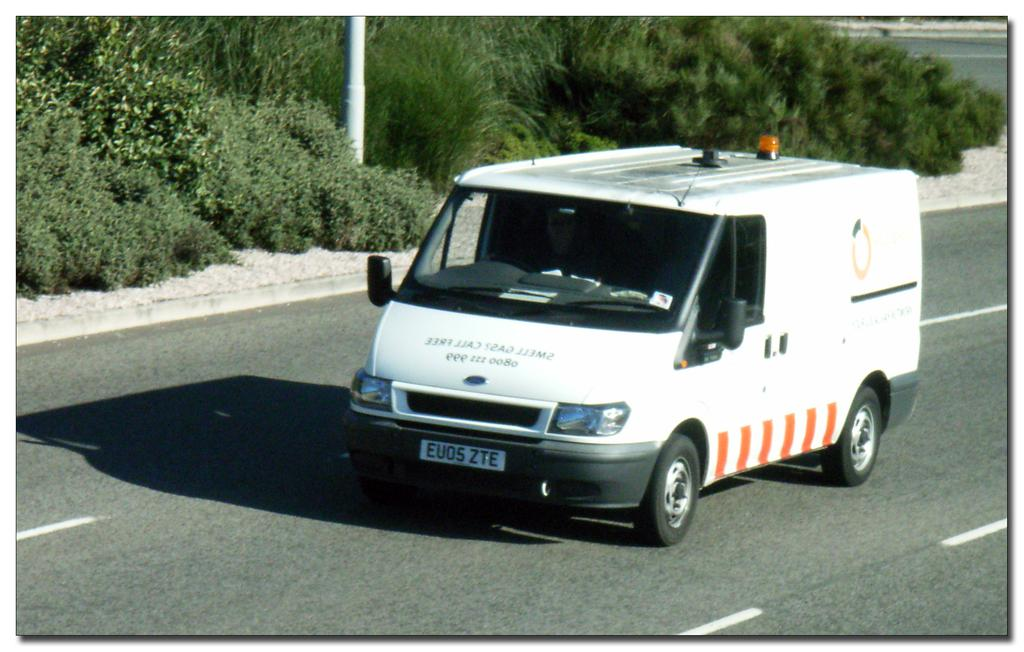<image>
Offer a succinct explanation of the picture presented. A white and orange van with front license plate EU05 ZTE 